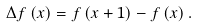<formula> <loc_0><loc_0><loc_500><loc_500>\Delta f \left ( x \right ) = f \left ( x + 1 \right ) - f \left ( x \right ) .</formula> 